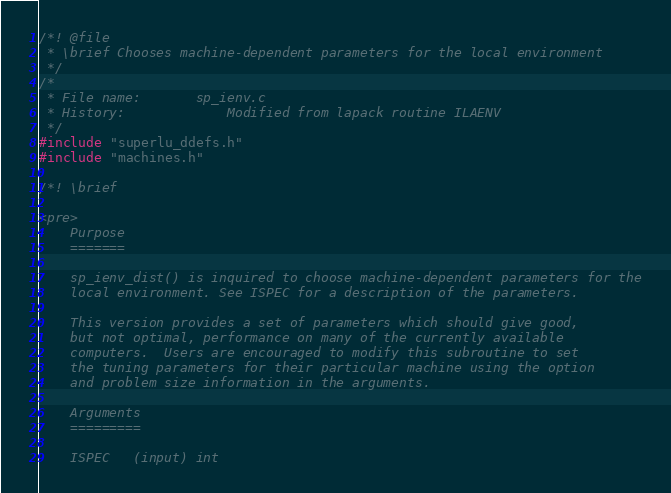Convert code to text. <code><loc_0><loc_0><loc_500><loc_500><_C_>/*! @file
 * \brief Chooses machine-dependent parameters for the local environment
 */
/*
 * File name:		sp_ienv.c
 * History:             Modified from lapack routine ILAENV
 */
#include "superlu_ddefs.h"
#include "machines.h"

/*! \brief

<pre>
    Purpose   
    =======   

    sp_ienv_dist() is inquired to choose machine-dependent parameters for the
    local environment. See ISPEC for a description of the parameters.   

    This version provides a set of parameters which should give good,   
    but not optimal, performance on many of the currently available   
    computers.  Users are encouraged to modify this subroutine to set   
    the tuning parameters for their particular machine using the option   
    and problem size information in the arguments.   

    Arguments   
    =========   

    ISPEC   (input) int</code> 